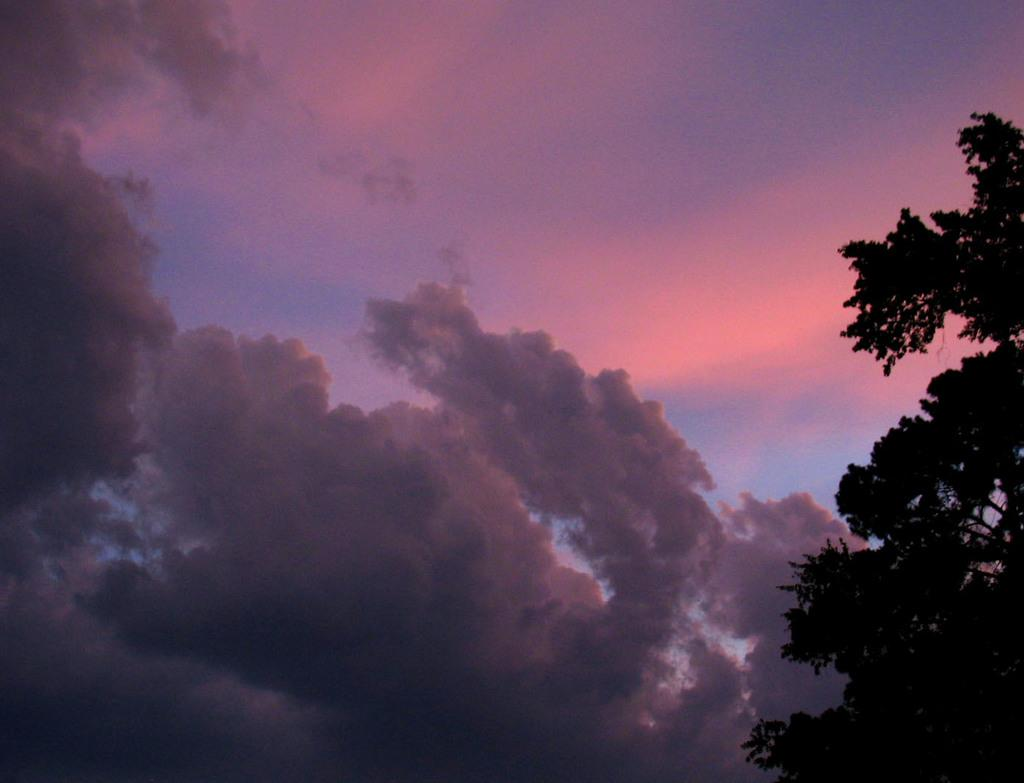What type of vegetation can be seen on the right side of the image? There is a tree on the right side of the image. What is visible in the background of the image? The sky is visible in the background of the image. What can be observed in the sky? Clouds are present in the sky. How many plants are present in the image, and who is the expert on these plants? There is only one tree visible in the image, and there is no information about an expert on plants in the image. 